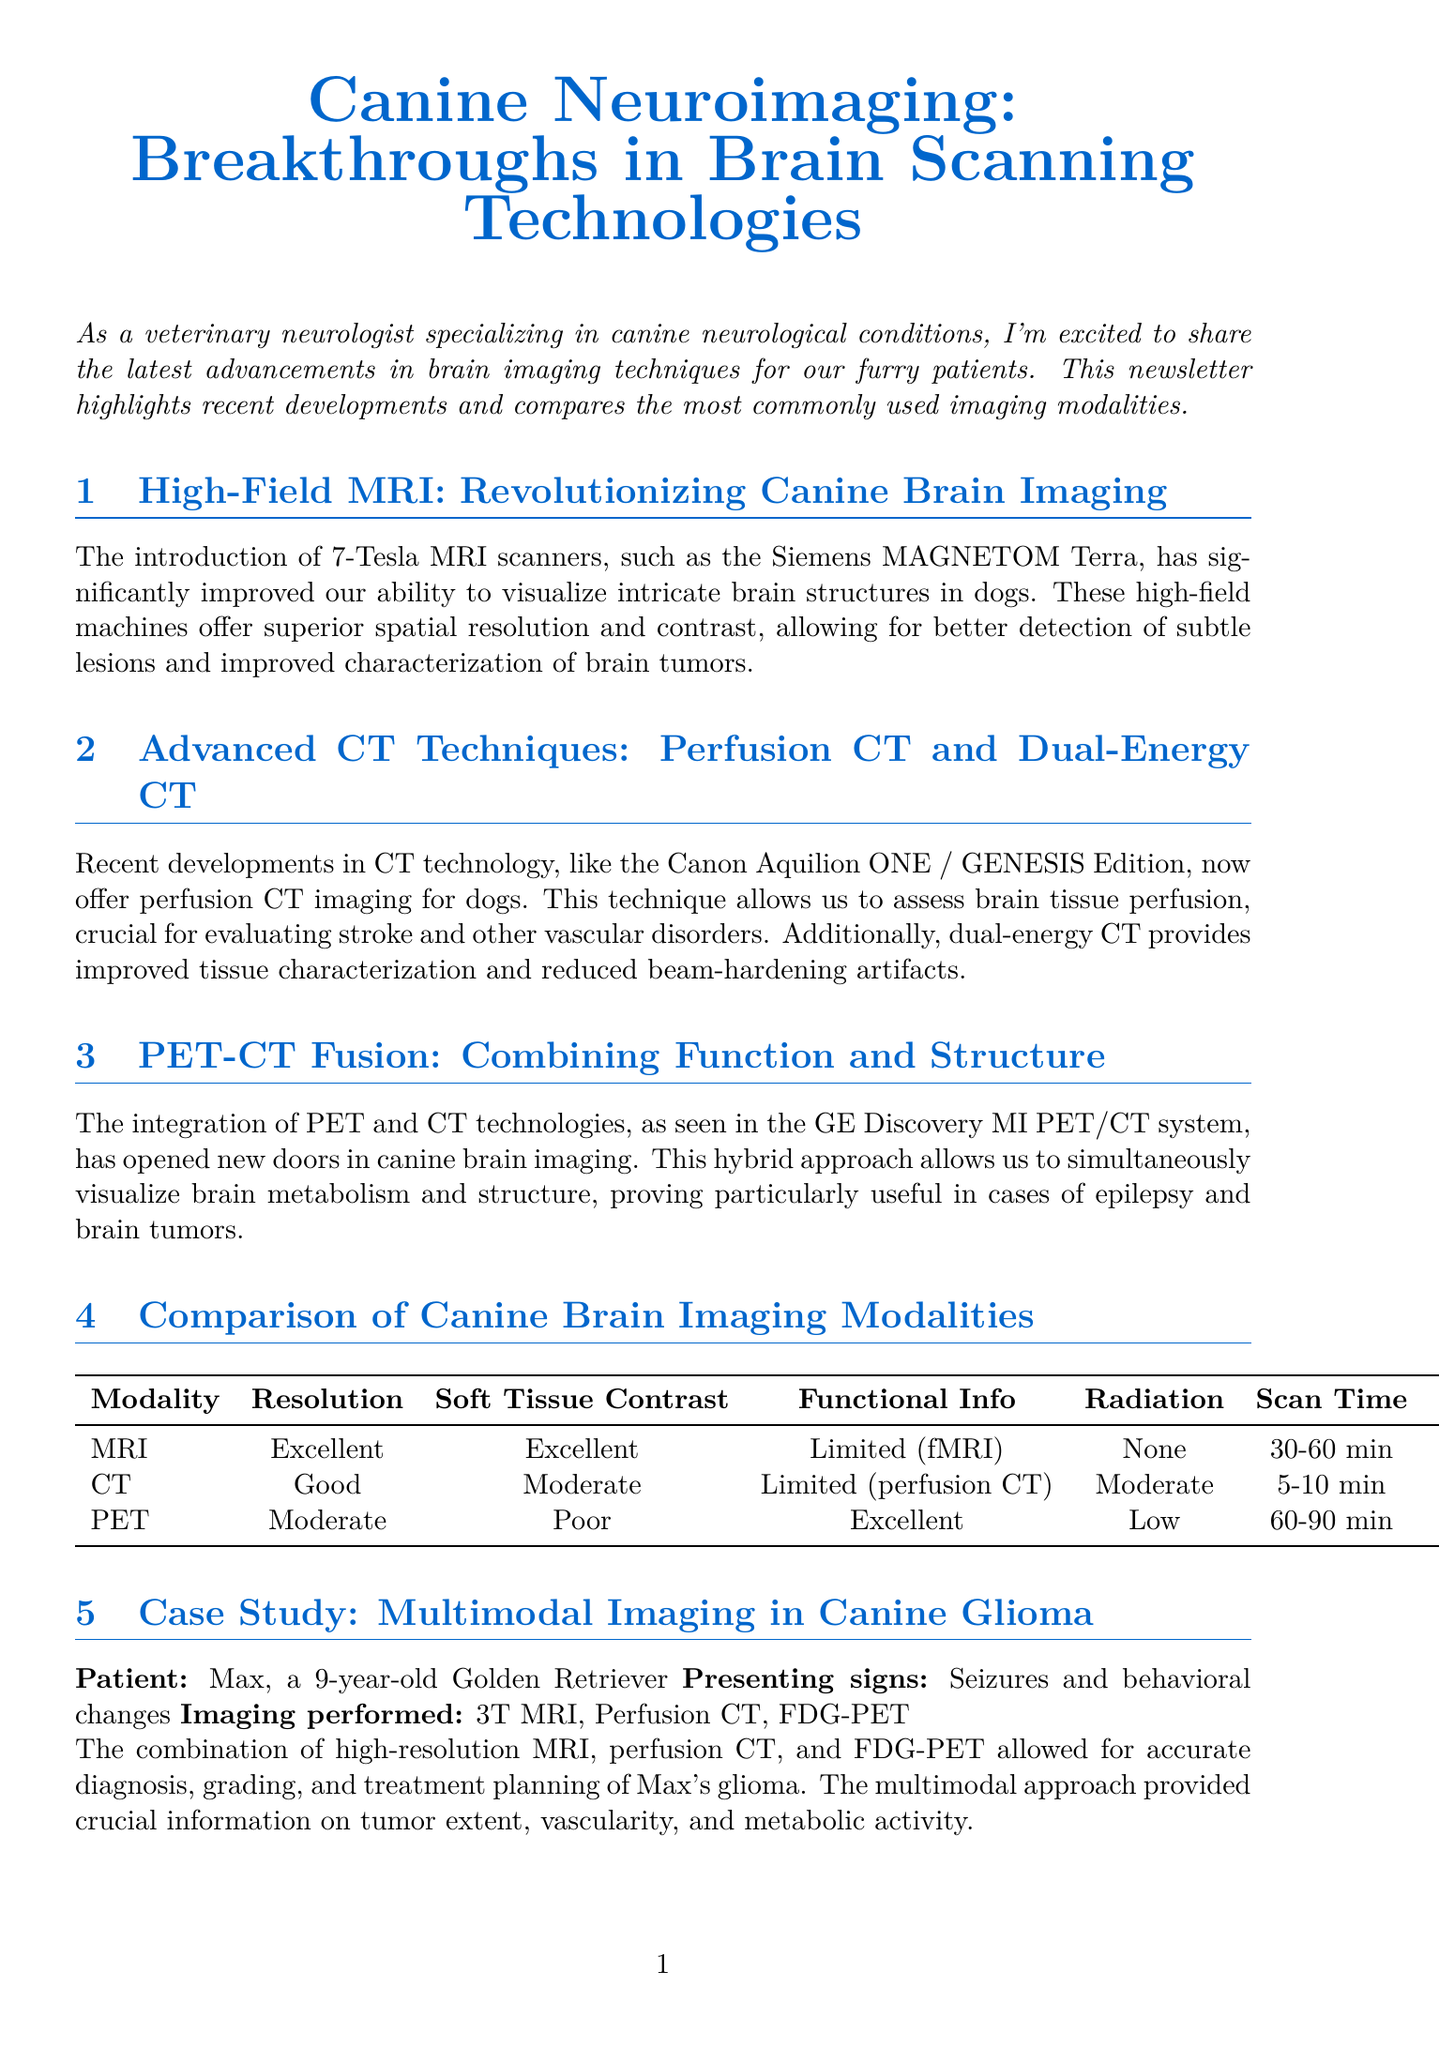What is the title of the newsletter? The title is prominently displayed at the top of the document, introducing the main theme of the newsletter.
Answer: Canine Neuroimaging: Breakthroughs in Brain Scanning Technologies What technology has revolutionized canine brain imaging according to the newsletter? The newsletter states that the introduction of high-field MRI scanners significantly improved brain imaging capabilities for dogs.
Answer: High-Field MRI What specific model of MRI scanner is mentioned? The content mentions a specific model, indicating a recent advancement in the field that has enhanced imaging quality.
Answer: Siemens MAGNETOM Terra Which imaging modality has no radiation exposure? The comparison chart provides details on radiation exposure for each imaging technique, indicating which ones are safer in this aspect.
Answer: MRI What condition was the case study, involving Max, specifically related to? The case study summarizes the presenting signs noted in the patient, hence focusing on a particular neurological condition.
Answer: Glioma How long does a CT scan typically take? The comparison chart includes information on scan duration for each modality, specifically highlighting the CT scan's duration.
Answer: 5-10 minutes Which imaging modality provides limited functional information, according to the comparison chart? The chart outlines the functional information category for each modality, revealing the limitations of certain scans.
Answer: MRI What are the emerging neuroimaging techniques mentioned in the newsletter? The future perspectives section lists potential advancements in neuroimaging that are expected to be developed.
Answer: Hyperpolarized 13C MRI, machine learning algorithms, diffusion tensor imaging What is the estimated cost range of a PET scan as per the comparison chart? The comparison chart provides an estimation of costs associated with various imaging modalities, highlighting expenses for PET scans.
Answer: High 